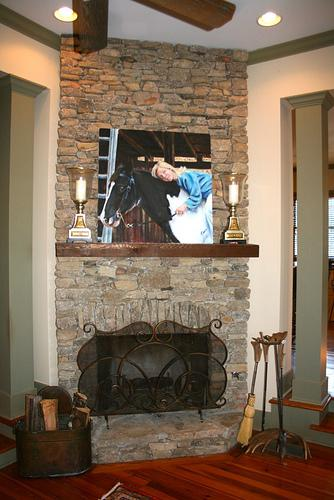How many candles and candle holders are there, and what color are the candles? There are two candle holders and one white candle located on the fireplace mantle. What is placed on the mantle of the fireplace? A candle holder and a picture of a woman on a horse are placed on the mantle of the fireplace. Can you please explain the flooring type and its color in the image? The flooring in the image is made of red stained hardwood with an ornate rug in the corner. Where are the light fixtures in the image and how many are there? There are two light fixtures in the image located on the ceiling, with one on the left and another on the right side. Identify the main features of this image in a concise manner. Fireplace, picture of a lady on a horse, ceiling lights, wooden floor, decorative rug corner, and fireplace accessories. What is the chimneysweeper and fireplace broom like? The brown chimneysweeper is a small broom used for cleaning, while the broom is located next to the chimney. What type of objects are placed near or in front of the fireplace? A broom, a brass wood container, container with logs, and a copper tub holding firewood are positioned near or in front of the fireplace. Describe the picture above the fireplace in a few words. A blonde woman with a draped blue garment is resting her head on the neck of a black and white horse. Please describe the predominant color scheme and materials in the room. The room predominantly features gray stone, brown wood, red stained hardwood floors, and a green column next to the fireplace. In a detailed sentence, describe what the fireplace looks like. The fireplace features gray bricks, an ornate screen, and a wooden beam mantle with matching candleholders, surrounded by rustic logs and tools. 